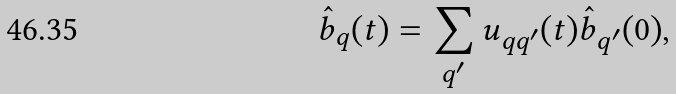<formula> <loc_0><loc_0><loc_500><loc_500>\hat { b } _ { q } ( t ) = \sum _ { q ^ { \prime } } u _ { q q ^ { \prime } } ( t ) \hat { b } _ { q ^ { \prime } } ( 0 ) ,</formula> 